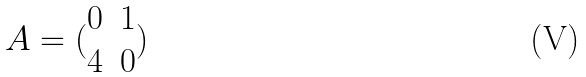Convert formula to latex. <formula><loc_0><loc_0><loc_500><loc_500>A = ( \begin{matrix} 0 & 1 \\ 4 & 0 \end{matrix} )</formula> 